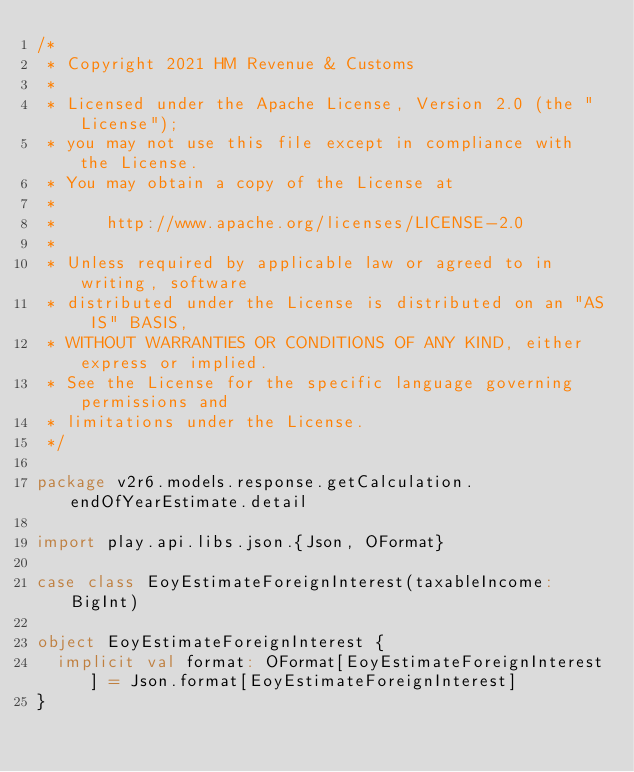Convert code to text. <code><loc_0><loc_0><loc_500><loc_500><_Scala_>/*
 * Copyright 2021 HM Revenue & Customs
 *
 * Licensed under the Apache License, Version 2.0 (the "License");
 * you may not use this file except in compliance with the License.
 * You may obtain a copy of the License at
 *
 *     http://www.apache.org/licenses/LICENSE-2.0
 *
 * Unless required by applicable law or agreed to in writing, software
 * distributed under the License is distributed on an "AS IS" BASIS,
 * WITHOUT WARRANTIES OR CONDITIONS OF ANY KIND, either express or implied.
 * See the License for the specific language governing permissions and
 * limitations under the License.
 */

package v2r6.models.response.getCalculation.endOfYearEstimate.detail

import play.api.libs.json.{Json, OFormat}

case class EoyEstimateForeignInterest(taxableIncome: BigInt)

object EoyEstimateForeignInterest {
  implicit val format: OFormat[EoyEstimateForeignInterest] = Json.format[EoyEstimateForeignInterest]
}</code> 